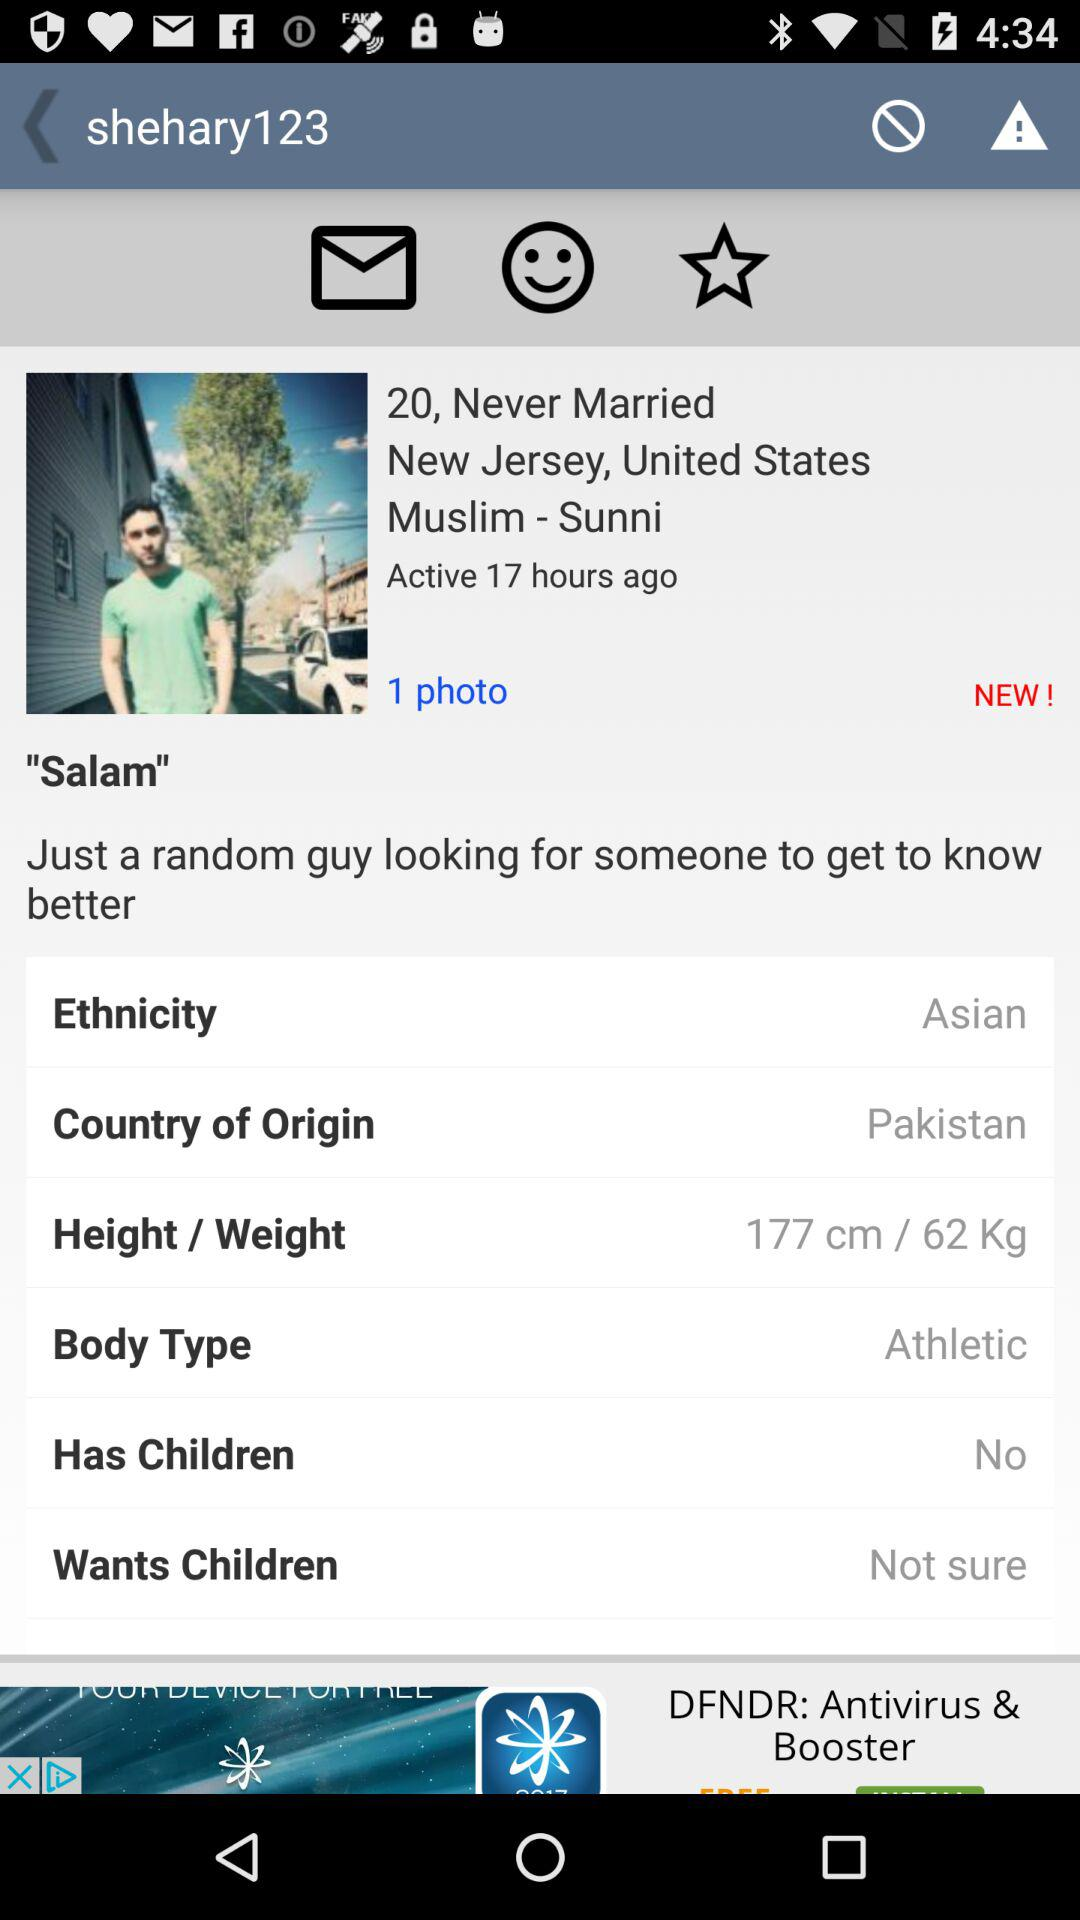What is the username? The username is Salam. 